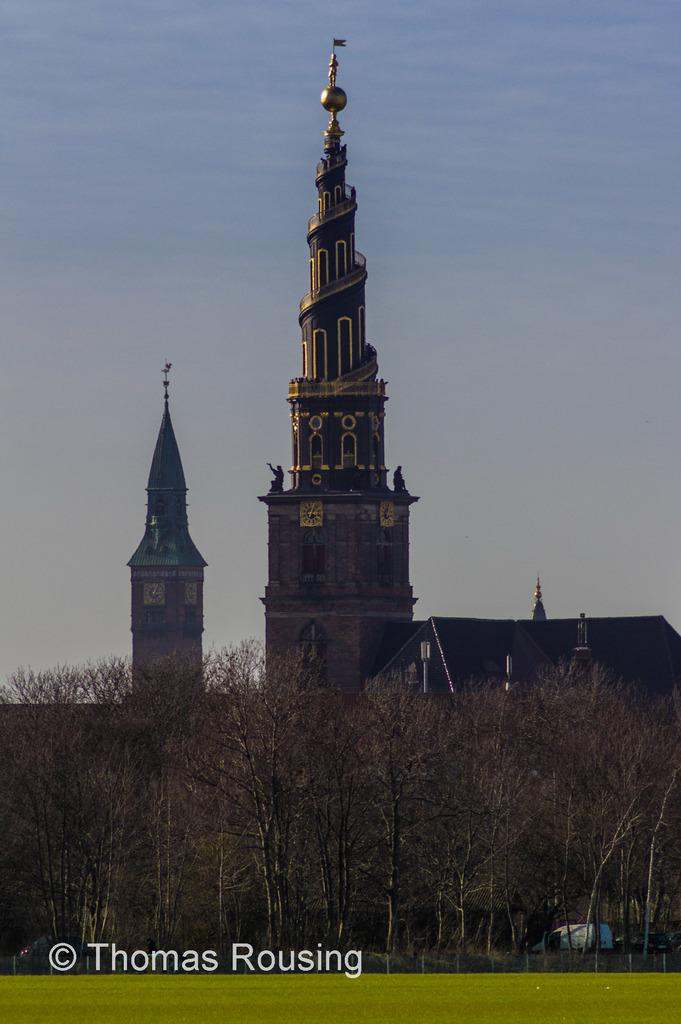What type of structures are visible in the image? There are buildings with windows in the image. What type of vegetation can be seen in the image? There are trees and grass in the image. What type of barrier is present in the image? There is a fence in the image. What can be seen in the background of the image? The sky with clouds is visible in the background of the image. What type of drum is being played by the country in the image? There is no country or drum present in the image. Is there a carpenter working on the buildings in the image? There is no indication of a carpenter or any construction work in progress in the image. 